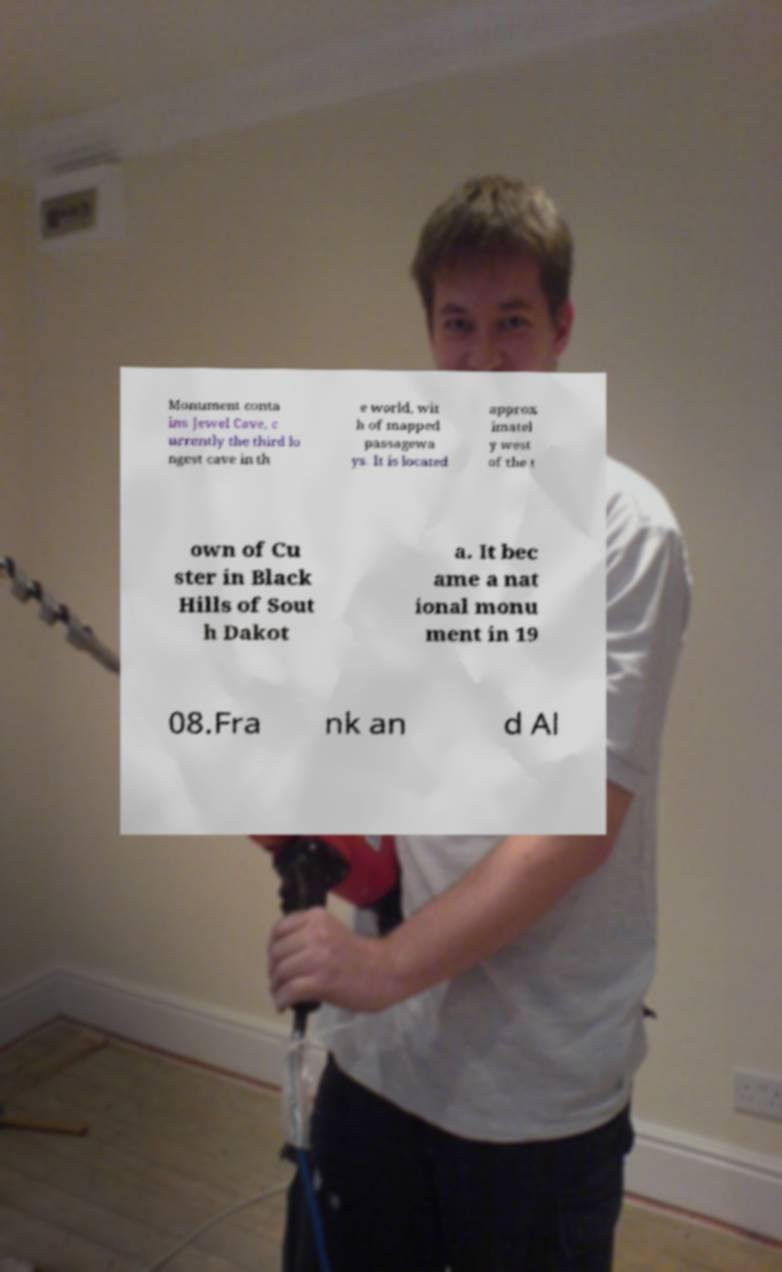There's text embedded in this image that I need extracted. Can you transcribe it verbatim? Monument conta ins Jewel Cave, c urrently the third lo ngest cave in th e world, wit h of mapped passagewa ys. It is located approx imatel y west of the t own of Cu ster in Black Hills of Sout h Dakot a. It bec ame a nat ional monu ment in 19 08.Fra nk an d Al 